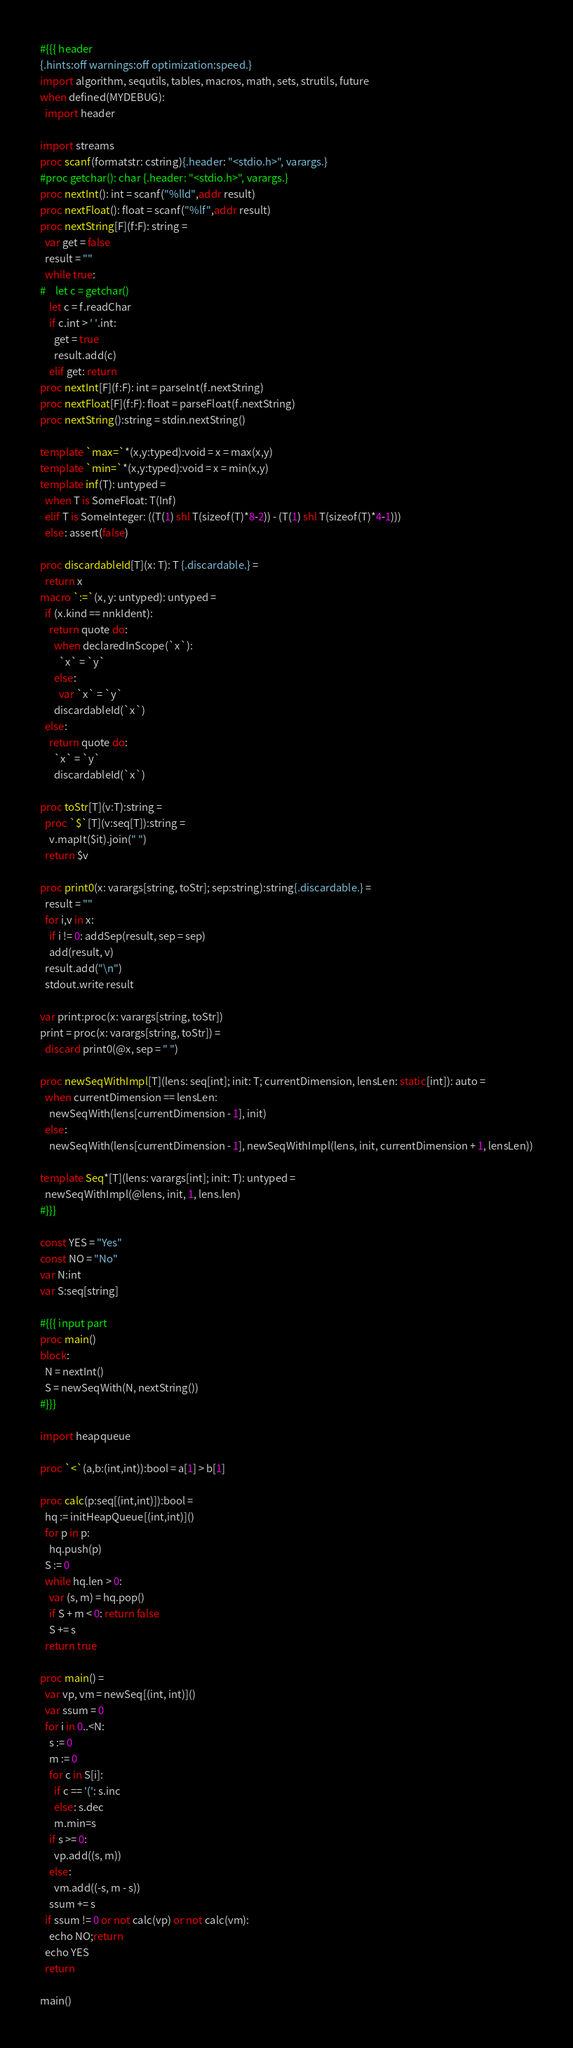<code> <loc_0><loc_0><loc_500><loc_500><_Nim_>#{{{ header
{.hints:off warnings:off optimization:speed.}
import algorithm, sequtils, tables, macros, math, sets, strutils, future
when defined(MYDEBUG):
  import header

import streams
proc scanf(formatstr: cstring){.header: "<stdio.h>", varargs.}
#proc getchar(): char {.header: "<stdio.h>", varargs.}
proc nextInt(): int = scanf("%lld",addr result)
proc nextFloat(): float = scanf("%lf",addr result)
proc nextString[F](f:F): string =
  var get = false
  result = ""
  while true:
#    let c = getchar()
    let c = f.readChar
    if c.int > ' '.int:
      get = true
      result.add(c)
    elif get: return
proc nextInt[F](f:F): int = parseInt(f.nextString)
proc nextFloat[F](f:F): float = parseFloat(f.nextString)
proc nextString():string = stdin.nextString()

template `max=`*(x,y:typed):void = x = max(x,y)
template `min=`*(x,y:typed):void = x = min(x,y)
template inf(T): untyped = 
  when T is SomeFloat: T(Inf)
  elif T is SomeInteger: ((T(1) shl T(sizeof(T)*8-2)) - (T(1) shl T(sizeof(T)*4-1)))
  else: assert(false)

proc discardableId[T](x: T): T {.discardable.} =
  return x
macro `:=`(x, y: untyped): untyped =
  if (x.kind == nnkIdent):
    return quote do:
      when declaredInScope(`x`):
        `x` = `y`
      else:
        var `x` = `y`
      discardableId(`x`)
  else:
    return quote do:
      `x` = `y`
      discardableId(`x`)

proc toStr[T](v:T):string =
  proc `$`[T](v:seq[T]):string =
    v.mapIt($it).join(" ")
  return $v

proc print0(x: varargs[string, toStr]; sep:string):string{.discardable.} =
  result = ""
  for i,v in x:
    if i != 0: addSep(result, sep = sep)
    add(result, v)
  result.add("\n")
  stdout.write result

var print:proc(x: varargs[string, toStr])
print = proc(x: varargs[string, toStr]) =
  discard print0(@x, sep = " ")

proc newSeqWithImpl[T](lens: seq[int]; init: T; currentDimension, lensLen: static[int]): auto =
  when currentDimension == lensLen:
    newSeqWith(lens[currentDimension - 1], init)
  else:
    newSeqWith(lens[currentDimension - 1], newSeqWithImpl(lens, init, currentDimension + 1, lensLen))

template Seq*[T](lens: varargs[int]; init: T): untyped =
  newSeqWithImpl(@lens, init, 1, lens.len)
#}}}

const YES = "Yes"
const NO = "No"
var N:int
var S:seq[string]

#{{{ input part
proc main()
block:
  N = nextInt()
  S = newSeqWith(N, nextString())
#}}}

import heapqueue

proc `<`(a,b:(int,int)):bool = a[1] > b[1]

proc calc(p:seq[(int,int)]):bool =
  hq := initHeapQueue[(int,int)]()
  for p in p:
    hq.push(p)
  S := 0
  while hq.len > 0:
    var (s, m) = hq.pop()
    if S + m < 0: return false
    S += s
  return true

proc main() =
  var vp, vm = newSeq[(int, int)]()
  var ssum = 0
  for i in 0..<N:
    s := 0
    m := 0
    for c in S[i]:
      if c == '(': s.inc
      else: s.dec
      m.min=s
    if s >= 0:
      vp.add((s, m))
    else:
      vm.add((-s, m - s))
    ssum += s
  if ssum != 0 or not calc(vp) or not calc(vm):
    echo NO;return
  echo YES
  return

main()
</code> 